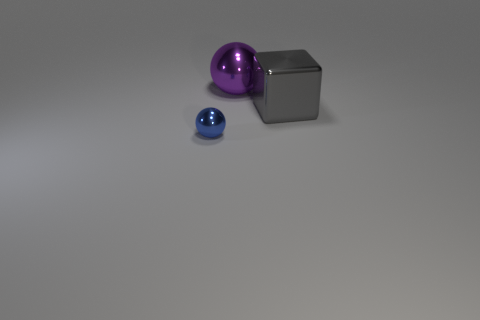Is the number of things less than the number of large purple metallic objects?
Your answer should be compact. No. There is a sphere that is behind the thing that is in front of the gray metallic object; are there any big purple balls behind it?
Give a very brief answer. No. How many rubber things are tiny blue objects or brown cylinders?
Give a very brief answer. 0. Does the tiny thing have the same color as the large metallic sphere?
Offer a terse response. No. What number of large metallic things are on the right side of the small blue ball?
Offer a very short reply. 2. What number of large metallic objects are to the left of the large metal block and in front of the big purple metal object?
Provide a succinct answer. 0. What is the shape of the other tiny thing that is the same material as the purple thing?
Offer a terse response. Sphere. Does the shiny sphere that is in front of the block have the same size as the shiny thing that is to the right of the purple object?
Your response must be concise. No. What is the color of the ball that is behind the tiny blue metallic sphere?
Provide a short and direct response. Purple. What is the sphere in front of the metal sphere that is right of the small blue shiny ball made of?
Your answer should be compact. Metal. 